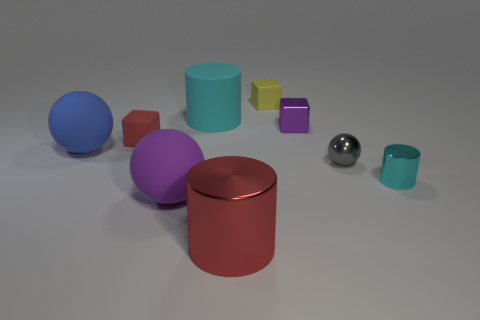There is a shiny thing that is the same size as the purple rubber thing; what shape is it?
Provide a short and direct response. Cylinder. Are there any gray metal balls right of the purple object that is behind the red thing left of the red cylinder?
Give a very brief answer. Yes. Is there anything else that is the same shape as the small gray shiny object?
Offer a very short reply. Yes. There is a rubber cube on the right side of the large metal cylinder; is its color the same as the matte object that is in front of the small gray ball?
Give a very brief answer. No. Are any tiny matte blocks visible?
Give a very brief answer. Yes. There is a object that is the same color as the tiny metal cylinder; what is its material?
Give a very brief answer. Rubber. How big is the matte cube that is left of the large cylinder behind the small cyan shiny cylinder that is behind the big red cylinder?
Provide a succinct answer. Small. There is a blue thing; is its shape the same as the purple thing that is in front of the tiny ball?
Your response must be concise. Yes. Are there any other large rubber cylinders of the same color as the rubber cylinder?
Provide a succinct answer. No. What number of blocks are either small blue things or tiny cyan metal objects?
Your response must be concise. 0. 